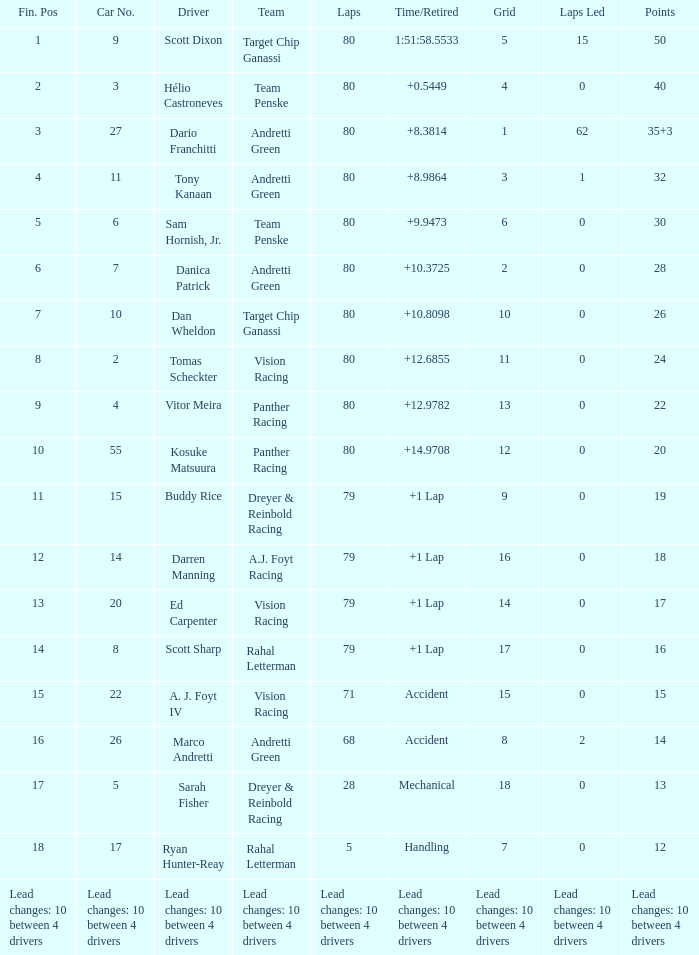What matrix consists of 24 points? 11.0. 